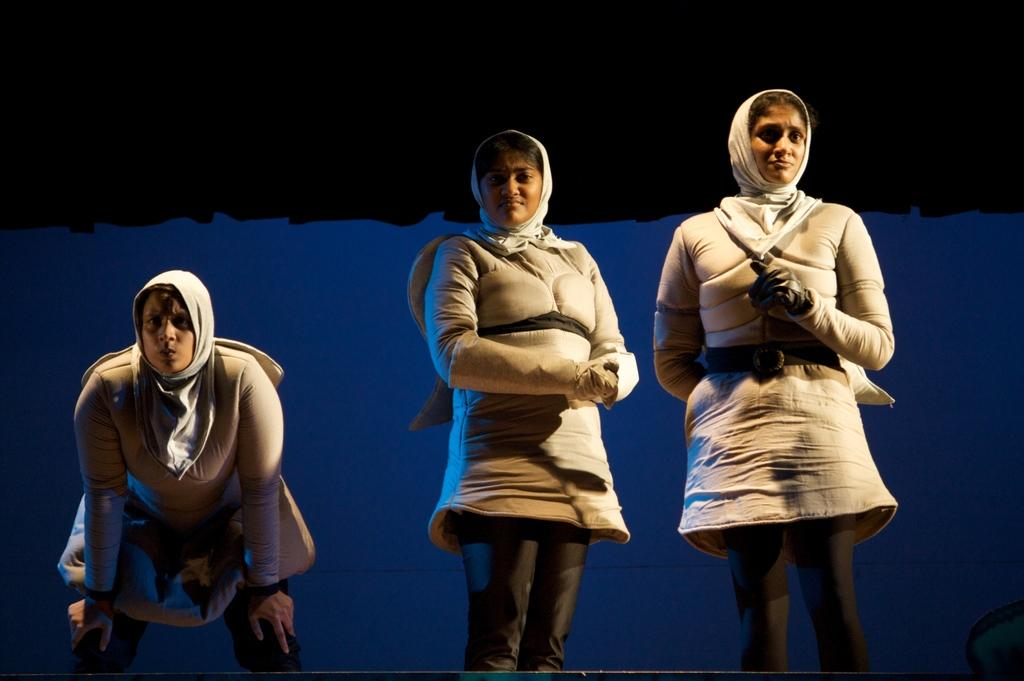How many people are in the image? There are three women in the image. What are the women doing in the image? The women are standing. What are the women wearing around their necks? The women are wearing scarfs. What type of shirt is the uncle wearing in the image? There is no uncle present in the image, and therefore no shirt to describe. 